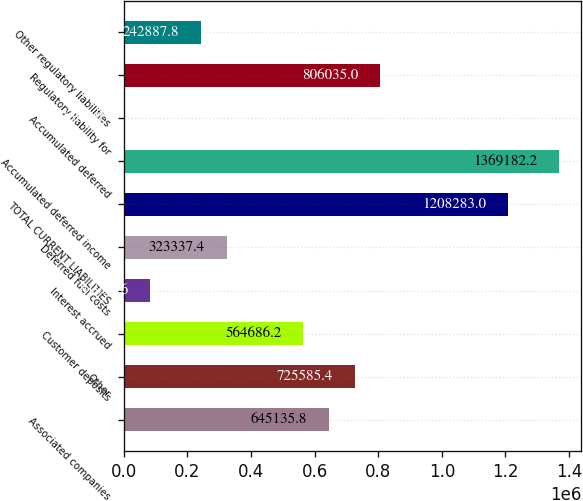Convert chart. <chart><loc_0><loc_0><loc_500><loc_500><bar_chart><fcel>Associated companies<fcel>Other<fcel>Customer deposits<fcel>Interest accrued<fcel>Deferred fuel costs<fcel>TOTAL CURRENT LIABILITIES<fcel>Accumulated deferred income<fcel>Accumulated deferred<fcel>Regulatory liability for<fcel>Other regulatory liabilities<nl><fcel>645136<fcel>725585<fcel>564686<fcel>81988.6<fcel>323337<fcel>1.20828e+06<fcel>1.36918e+06<fcel>1539<fcel>806035<fcel>242888<nl></chart> 